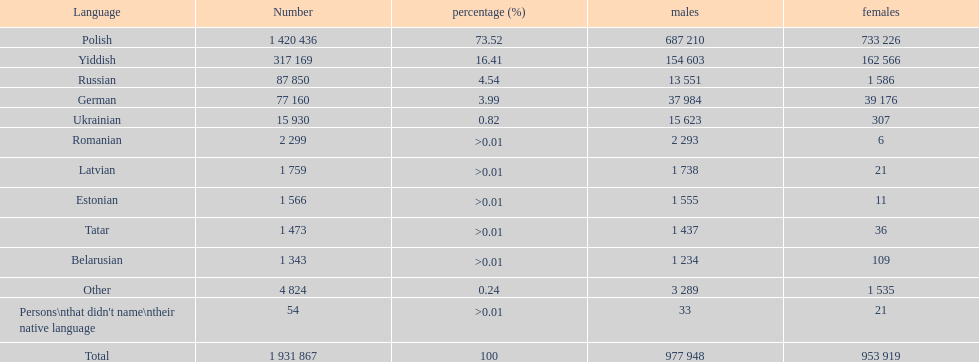01? Romanian. 